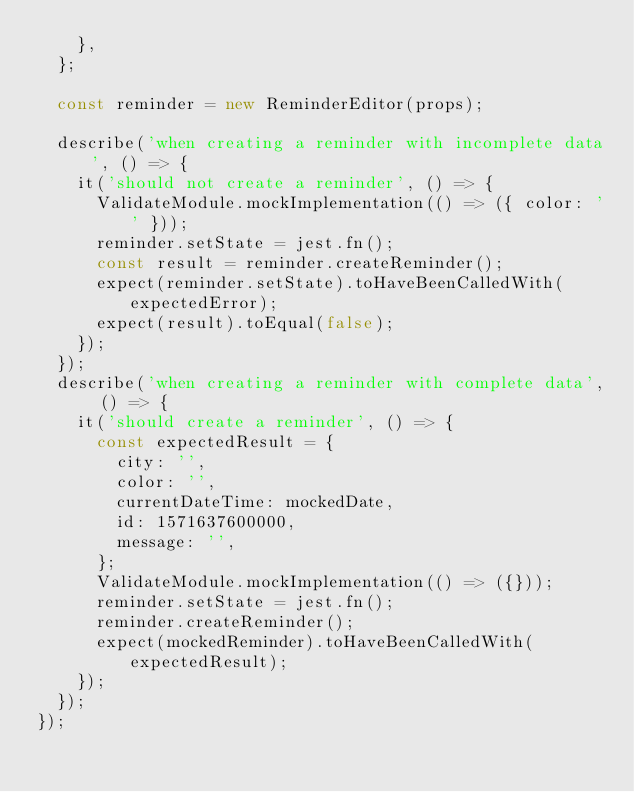<code> <loc_0><loc_0><loc_500><loc_500><_JavaScript_>    },
  };

  const reminder = new ReminderEditor(props);

  describe('when creating a reminder with incomplete data', () => {
    it('should not create a reminder', () => {
      ValidateModule.mockImplementation(() => ({ color: '' }));
      reminder.setState = jest.fn();
      const result = reminder.createReminder();
      expect(reminder.setState).toHaveBeenCalledWith(expectedError);
      expect(result).toEqual(false);
    });
  });
  describe('when creating a reminder with complete data', () => {
    it('should create a reminder', () => {
      const expectedResult = {
        city: '',
        color: '',
        currentDateTime: mockedDate,
        id: 1571637600000,
        message: '',
      };
      ValidateModule.mockImplementation(() => ({}));
      reminder.setState = jest.fn();
      reminder.createReminder();
      expect(mockedReminder).toHaveBeenCalledWith(expectedResult);
    });
  });
});
</code> 